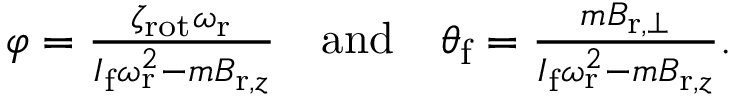Convert formula to latex. <formula><loc_0><loc_0><loc_500><loc_500>\begin{array} { r } { \varphi = \frac { \zeta _ { r o t } \omega _ { r } } { I _ { f } \omega _ { r } ^ { 2 } - m B _ { r , z } } \quad a n d \quad \theta _ { f } = \frac { m B _ { r , \perp } } { I _ { f } \omega _ { r } ^ { 2 } - m B _ { r , z } } . } \end{array}</formula> 